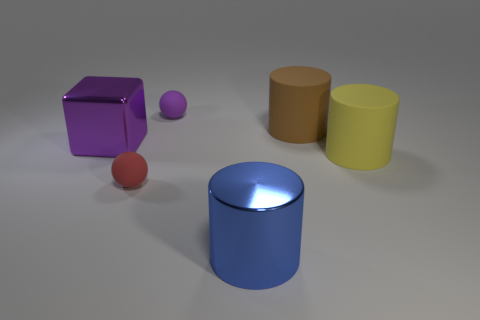Add 2 purple cubes. How many objects exist? 8 Subtract all balls. How many objects are left? 4 Subtract 1 brown cylinders. How many objects are left? 5 Subtract all tiny brown matte cylinders. Subtract all matte things. How many objects are left? 2 Add 6 metal cylinders. How many metal cylinders are left? 7 Add 1 spheres. How many spheres exist? 3 